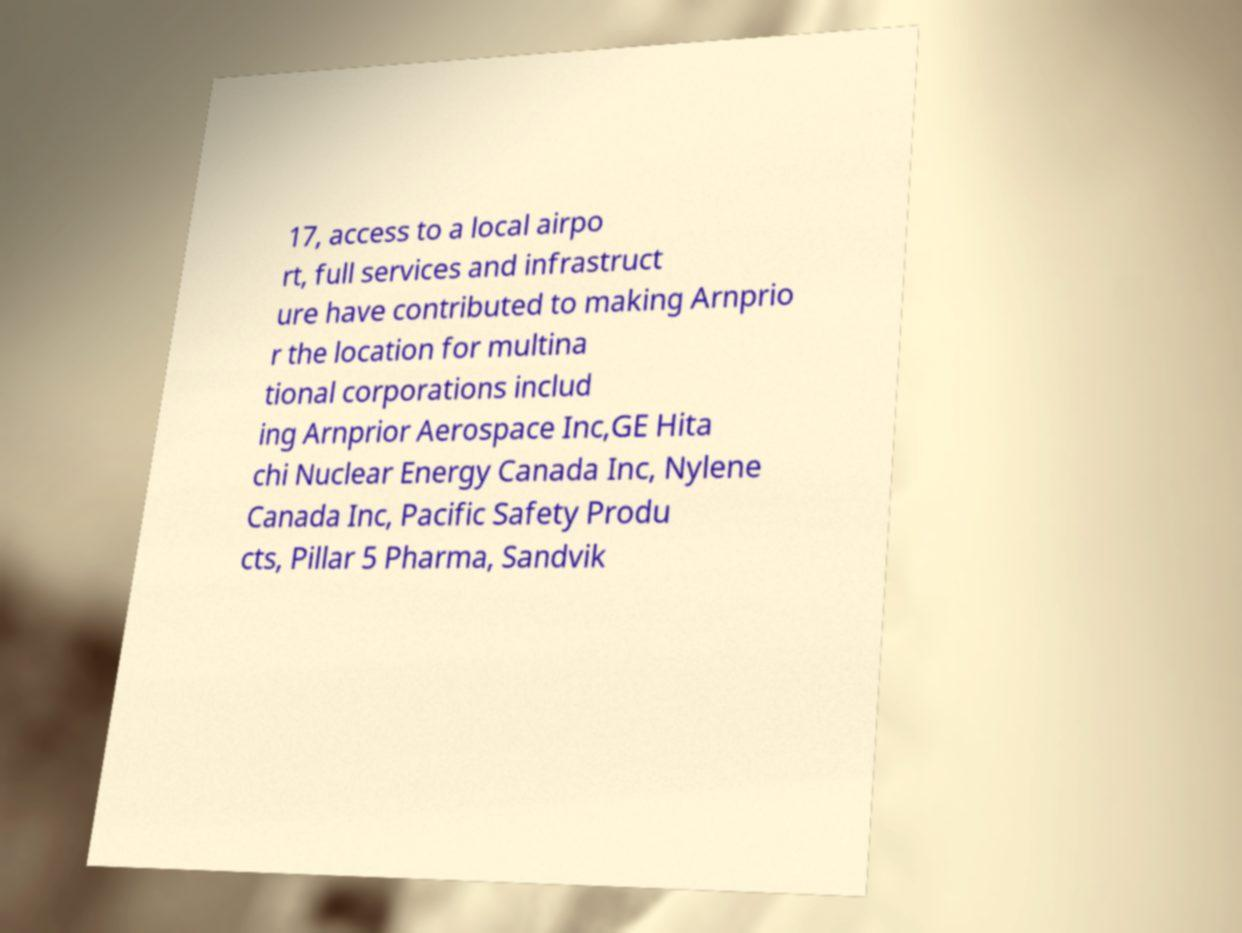Can you read and provide the text displayed in the image?This photo seems to have some interesting text. Can you extract and type it out for me? 17, access to a local airpo rt, full services and infrastruct ure have contributed to making Arnprio r the location for multina tional corporations includ ing Arnprior Aerospace Inc,GE Hita chi Nuclear Energy Canada Inc, Nylene Canada Inc, Pacific Safety Produ cts, Pillar 5 Pharma, Sandvik 